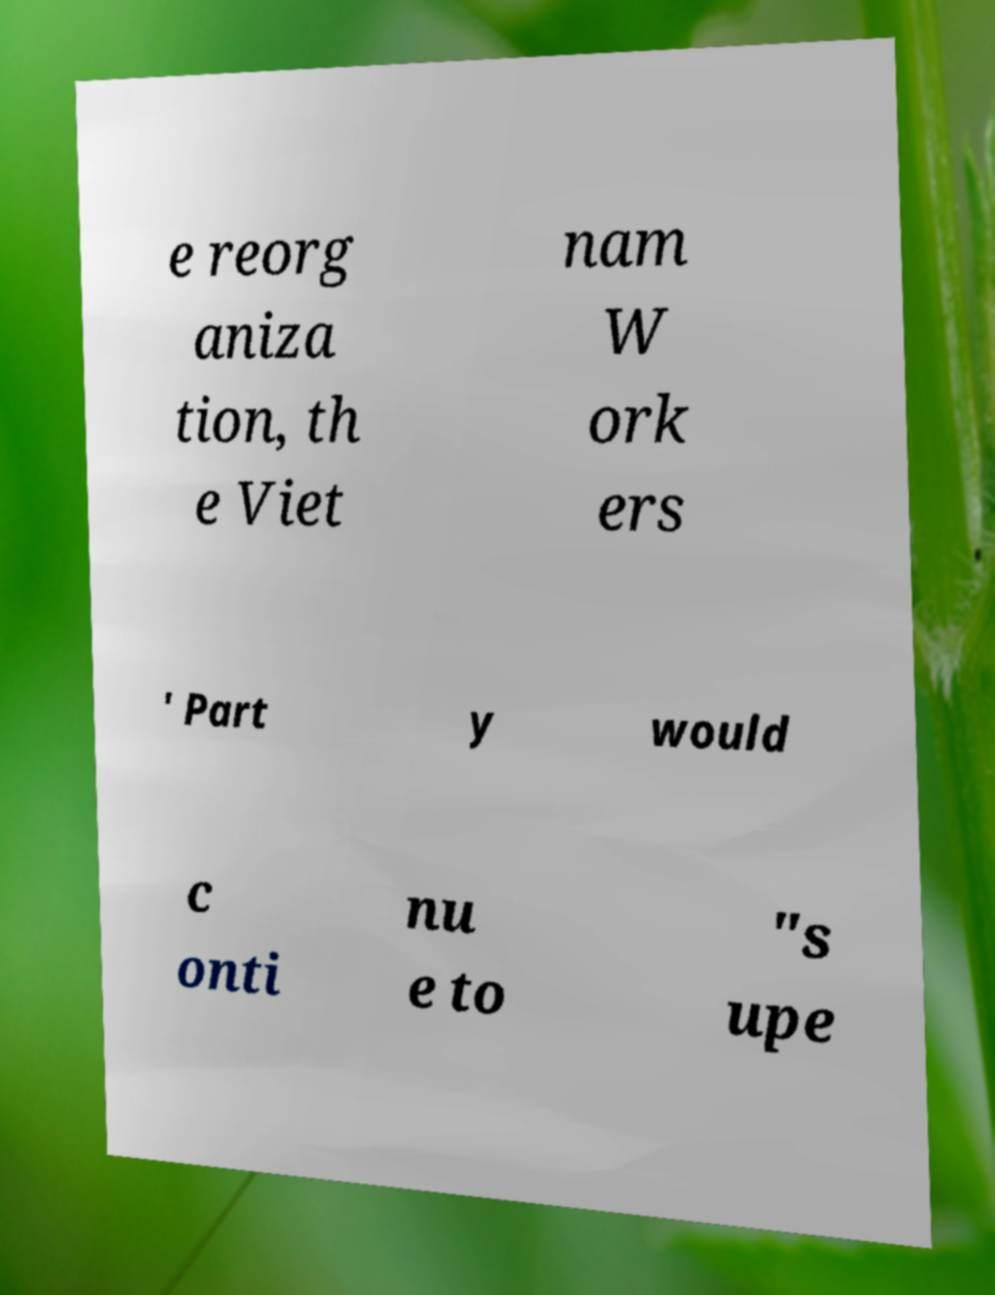Could you assist in decoding the text presented in this image and type it out clearly? e reorg aniza tion, th e Viet nam W ork ers ' Part y would c onti nu e to "s upe 